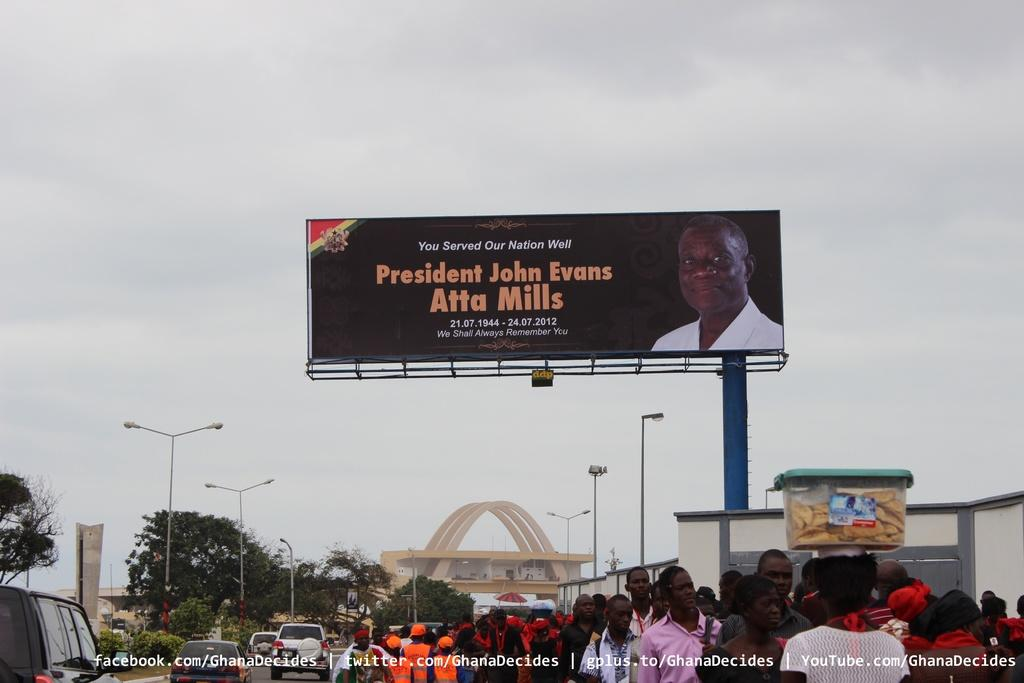<image>
Write a terse but informative summary of the picture. A billboard that says president john evans atta mills 